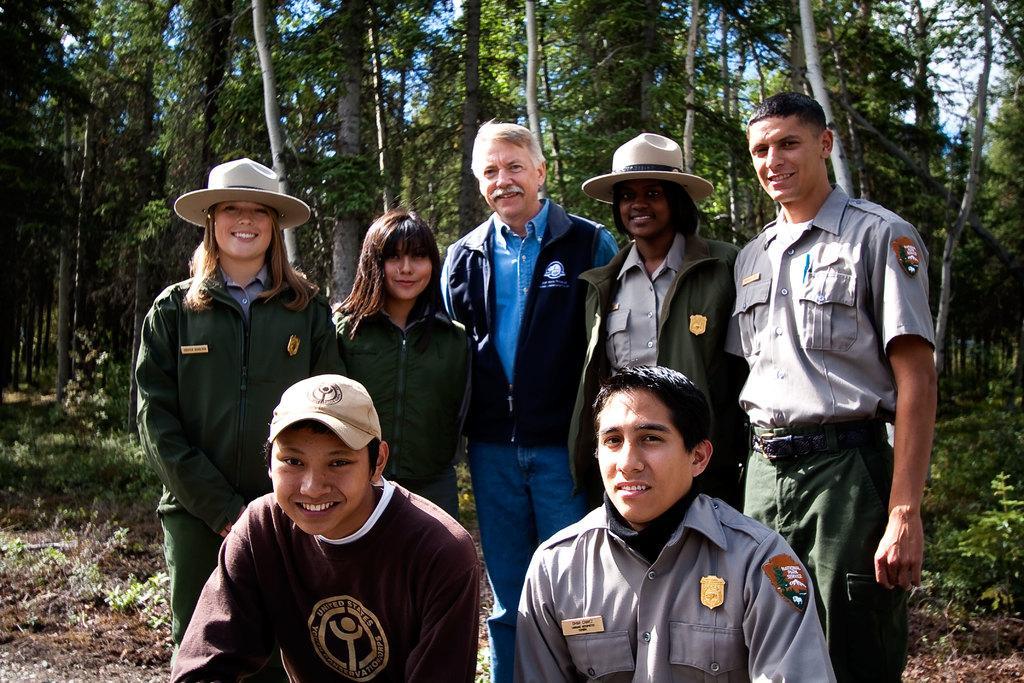How would you summarize this image in a sentence or two? This picture shows few people standing and few of them wore caps on their heads and we see trees and few plants on the ground. 